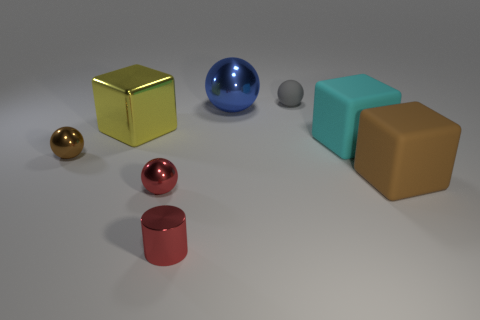Are there fewer brown cubes that are right of the brown matte cube than large things on the right side of the yellow shiny object?
Keep it short and to the point. Yes. There is a thing that is the same color as the metallic cylinder; what is its material?
Give a very brief answer. Metal. Are there any other things that are the same shape as the yellow object?
Ensure brevity in your answer.  Yes. What is the material of the brown thing to the left of the small rubber object?
Your answer should be very brief. Metal. Are there any rubber things right of the large metallic sphere?
Provide a succinct answer. Yes. What is the shape of the large brown rubber object?
Ensure brevity in your answer.  Cube. What number of objects are tiny objects that are in front of the cyan rubber block or blue shiny spheres?
Provide a succinct answer. 4. How many other things are there of the same color as the large shiny ball?
Offer a very short reply. 0. Is the color of the shiny cylinder the same as the metal sphere in front of the tiny brown metallic sphere?
Provide a short and direct response. Yes. There is a rubber object that is the same shape as the tiny brown shiny thing; what is its color?
Keep it short and to the point. Gray. 